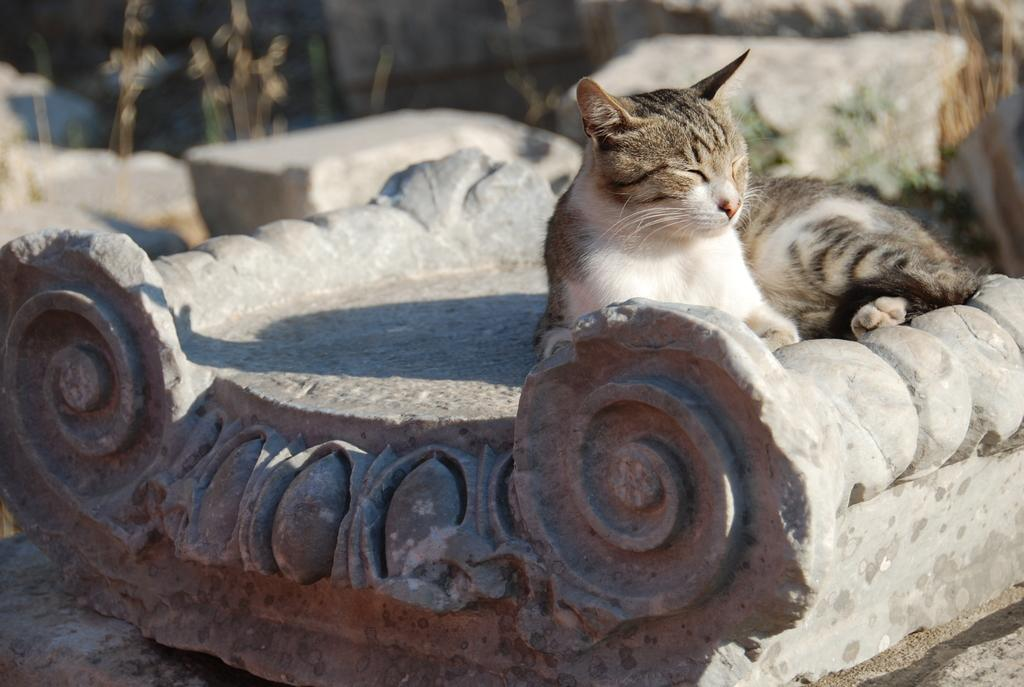What type of animal is present in the image? There is a cat in the image. What type of structures can be seen in the image? There are concrete structures in the image. Can you describe the background of the image? The background of the image is blurred. What type of basin is visible in the image? There is no basin present in the image. What pets are interacting with the cat in the image? The image only features a cat, and there are no other pets present. 